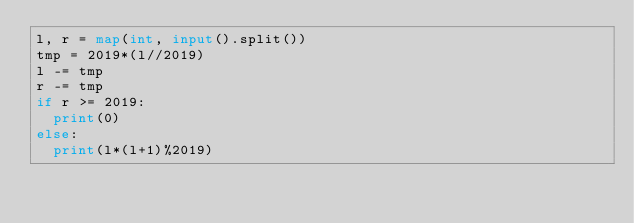Convert code to text. <code><loc_0><loc_0><loc_500><loc_500><_Python_>l, r = map(int, input().split())
tmp = 2019*(l//2019)
l -= tmp
r -= tmp
if r >= 2019:
  print(0)
else:
  print(l*(l+1)%2019)</code> 